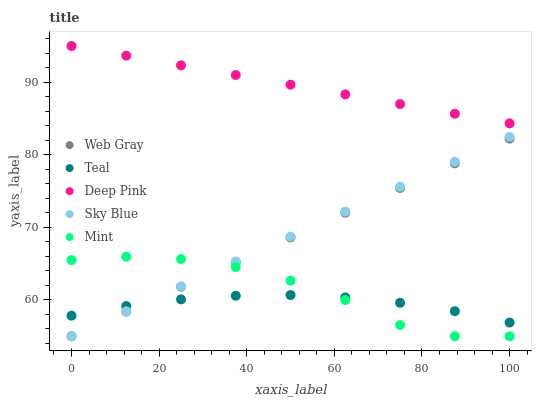Does Teal have the minimum area under the curve?
Answer yes or no. Yes. Does Deep Pink have the maximum area under the curve?
Answer yes or no. Yes. Does Web Gray have the minimum area under the curve?
Answer yes or no. No. Does Web Gray have the maximum area under the curve?
Answer yes or no. No. Is Sky Blue the smoothest?
Answer yes or no. Yes. Is Mint the roughest?
Answer yes or no. Yes. Is Web Gray the smoothest?
Answer yes or no. No. Is Web Gray the roughest?
Answer yes or no. No. Does Sky Blue have the lowest value?
Answer yes or no. Yes. Does Teal have the lowest value?
Answer yes or no. No. Does Deep Pink have the highest value?
Answer yes or no. Yes. Does Web Gray have the highest value?
Answer yes or no. No. Is Teal less than Deep Pink?
Answer yes or no. Yes. Is Deep Pink greater than Sky Blue?
Answer yes or no. Yes. Does Sky Blue intersect Teal?
Answer yes or no. Yes. Is Sky Blue less than Teal?
Answer yes or no. No. Is Sky Blue greater than Teal?
Answer yes or no. No. Does Teal intersect Deep Pink?
Answer yes or no. No. 